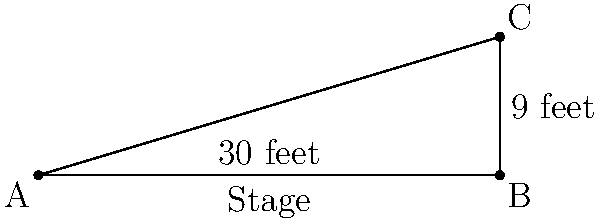On a soap opera set, two stars are standing on opposite sides of a rectangular stage. The stage is 30 feet wide and 9 feet deep. If one star is at the front left corner and the other is at the back right corner, how far apart are they? Let's solve this step-by-step:

1. We can visualize this as a right triangle, where:
   - The width of the stage (30 feet) is the base of the triangle
   - The depth of the stage (9 feet) is the height of the triangle
   - The distance between the stars is the hypotenuse of the triangle

2. We can use the Pythagorean theorem to find the hypotenuse:
   $a^2 + b^2 = c^2$, where $c$ is the hypotenuse

3. Let's plug in our values:
   $30^2 + 9^2 = c^2$

4. Simplify:
   $900 + 81 = c^2$
   $981 = c^2$

5. Take the square root of both sides:
   $\sqrt{981} = c$

6. Simplify:
   $c \approx 31.32$ feet

Therefore, the distance between the two soap opera stars is approximately 31.32 feet.
Answer: $31.32$ feet 